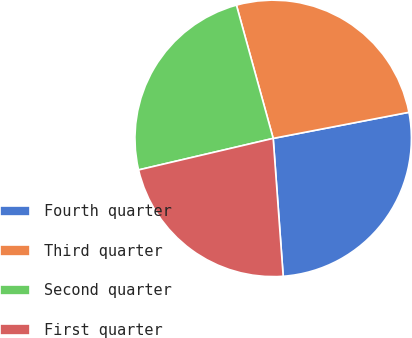Convert chart. <chart><loc_0><loc_0><loc_500><loc_500><pie_chart><fcel>Fourth quarter<fcel>Third quarter<fcel>Second quarter<fcel>First quarter<nl><fcel>26.87%<fcel>26.26%<fcel>24.38%<fcel>22.49%<nl></chart> 